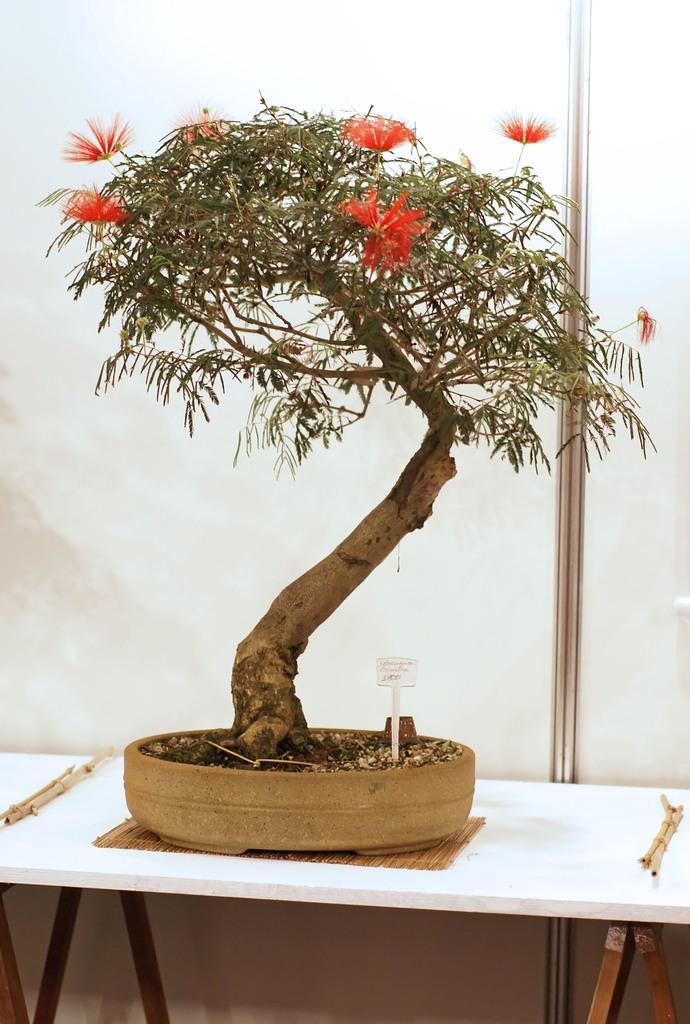In one or two sentences, can you explain what this image depicts? In the center of the image there is a table. On the table we can see pot, plant, flowers, board, sticks. In the background of the image we can see the wall. 